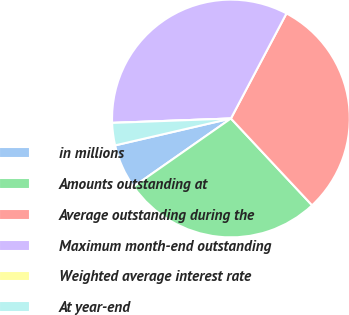Convert chart to OTSL. <chart><loc_0><loc_0><loc_500><loc_500><pie_chart><fcel>in millions<fcel>Amounts outstanding at<fcel>Average outstanding during the<fcel>Maximum month-end outstanding<fcel>Weighted average interest rate<fcel>At year-end<nl><fcel>6.08%<fcel>27.25%<fcel>30.29%<fcel>33.33%<fcel>0.0%<fcel>3.04%<nl></chart> 